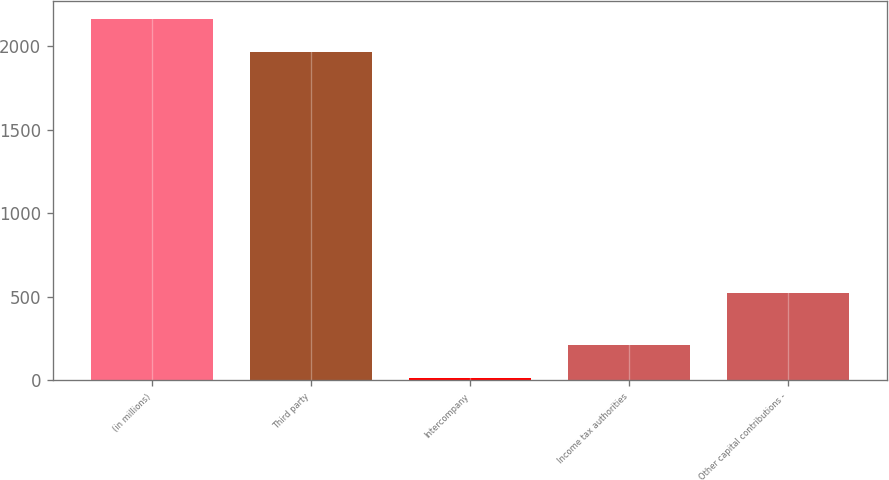Convert chart to OTSL. <chart><loc_0><loc_0><loc_500><loc_500><bar_chart><fcel>(in millions)<fcel>Third party<fcel>Intercompany<fcel>Income tax authorities<fcel>Other capital contributions -<nl><fcel>2163.1<fcel>1963<fcel>12<fcel>212.1<fcel>523<nl></chart> 